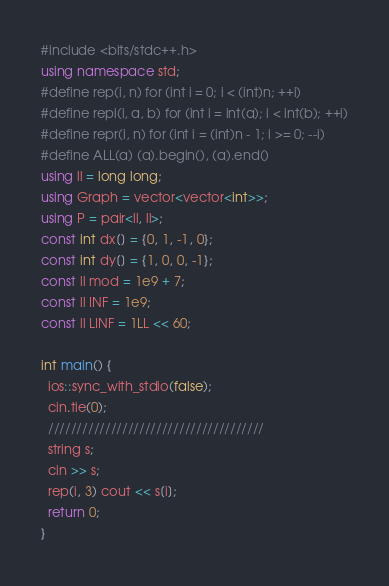Convert code to text. <code><loc_0><loc_0><loc_500><loc_500><_C++_>#include <bits/stdc++.h>
using namespace std;
#define rep(i, n) for (int i = 0; i < (int)n; ++i)
#define repi(i, a, b) for (int i = int(a); i < int(b); ++i)
#define repr(i, n) for (int i = (int)n - 1; i >= 0; --i)
#define ALL(a) (a).begin(), (a).end()
using ll = long long;
using Graph = vector<vector<int>>;
using P = pair<ll, ll>;
const int dx[] = {0, 1, -1, 0};
const int dy[] = {1, 0, 0, -1};
const ll mod = 1e9 + 7;
const ll INF = 1e9;
const ll LINF = 1LL << 60;

int main() {
  ios::sync_with_stdio(false);
  cin.tie(0);
  //////////////////////////////////////
  string s;
  cin >> s;
  rep(i, 3) cout << s[i];
  return 0;
}
</code> 